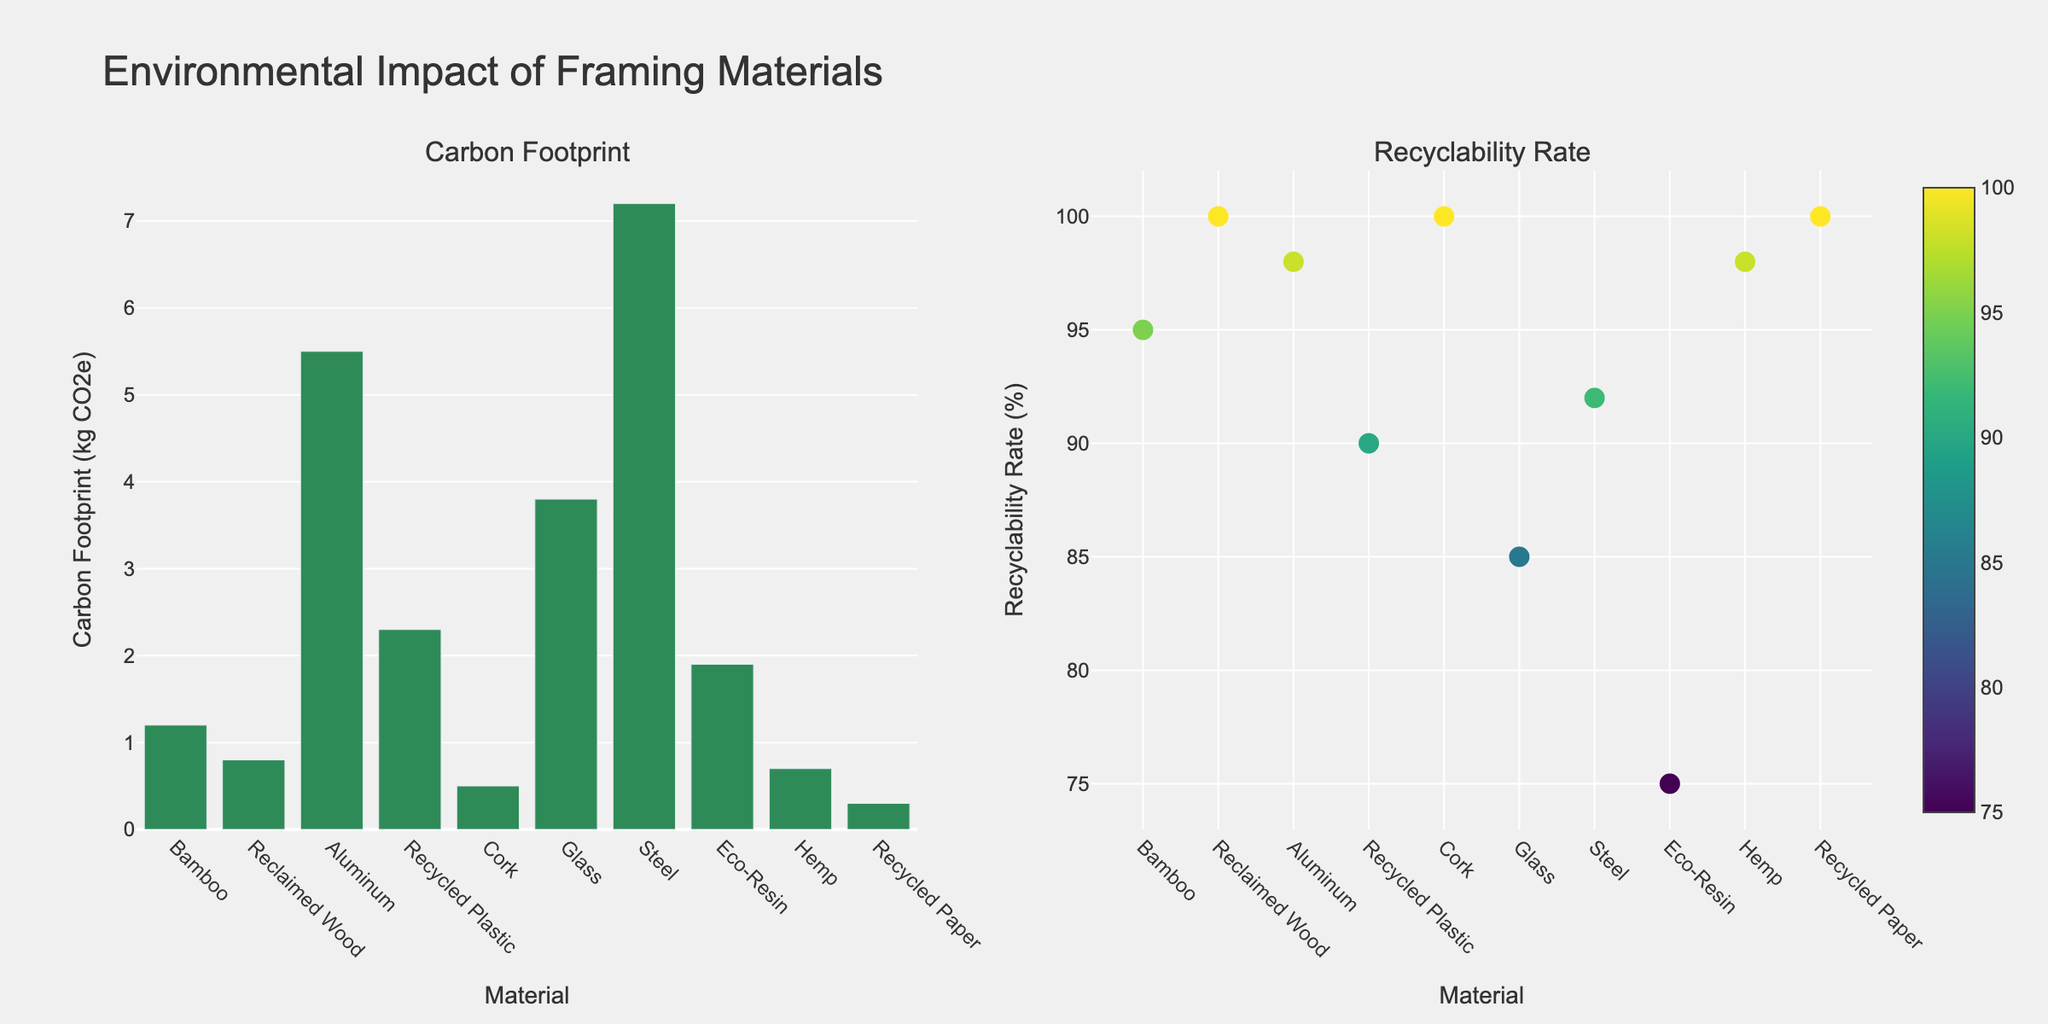What is the title of the figure? The title is located at the top center of the plot. It reads "Environmental Impact of Framing Materials".
Answer: Environmental Impact of Framing Materials Which material has the lowest carbon footprint? By observing the heights of the bars in the Carbon Footprint subplot, Recycled Paper has the shortest bar, indicating the lowest carbon footprint.
Answer: Recycled Paper What is the recyclability rate for Aluminum? By locating Aluminum on the scatter plot for Recyclability Rate and looking at its corresponding y-axis value, the rate is found to be 98%.
Answer: 98% How does the carbon footprint of Steel compare to that of Eco-Resin? Comparing the heights of the bars for Steel and Eco-Resin in the Carbon Footprint subplot, Steel has a taller bar indicating a higher carbon footprint.
Answer: Steel's carbon footprint is higher than Eco-Resin's Which two materials have a recyclability rate of 100%? By looking at the scatter points aligned at the 100% mark on the y-axis of the Recyclability Rate subplot, these materials are Reclaimed Wood, Cork, and Recycled Paper.
Answer: Reclaimed Wood, Cork, and Recycled Paper What is the difference in recyclability rate between Glass and Eco-Resin? By finding the y-axis values for Glass (85%) and Eco-Resin (75%) in the Recyclability Rate subplot, the difference is calculated as 85% - 75% = 10%.
Answer: 10% Which material has the highest carbon footprint, and what is its value? By identifying the tallest bar in the Carbon Footprint subplot, Steel stands out, having the highest value at 7.2 kg CO2e.
Answer: Steel, 7.2 kg CO2e Are there any materials that have both low carbon footprints and high recyclability rates? By cross-referencing the two subplots, Cork, Hemp, and Recycled Paper have low bars in the Carbon Footprint subplot and near-top positions in the Recyclability Rate subplot.
Answer: Cork, Hemp, and Recycled Paper What is the average recyclability rate of all materials depicted? Summing the recyclability rates: (95 + 100 + 98 + 90 + 100 + 85 + 92 + 75 + 98 + 100) = 933, and dividing by the number of materials (10), gives 933/10 = 93.3%.
Answer: 93.3% What color is used to represent the Carbon Footprint bars? Observing the bars in the Carbon Footprint subplot, they are uniformly colored in a greenish hue.
Answer: Green 